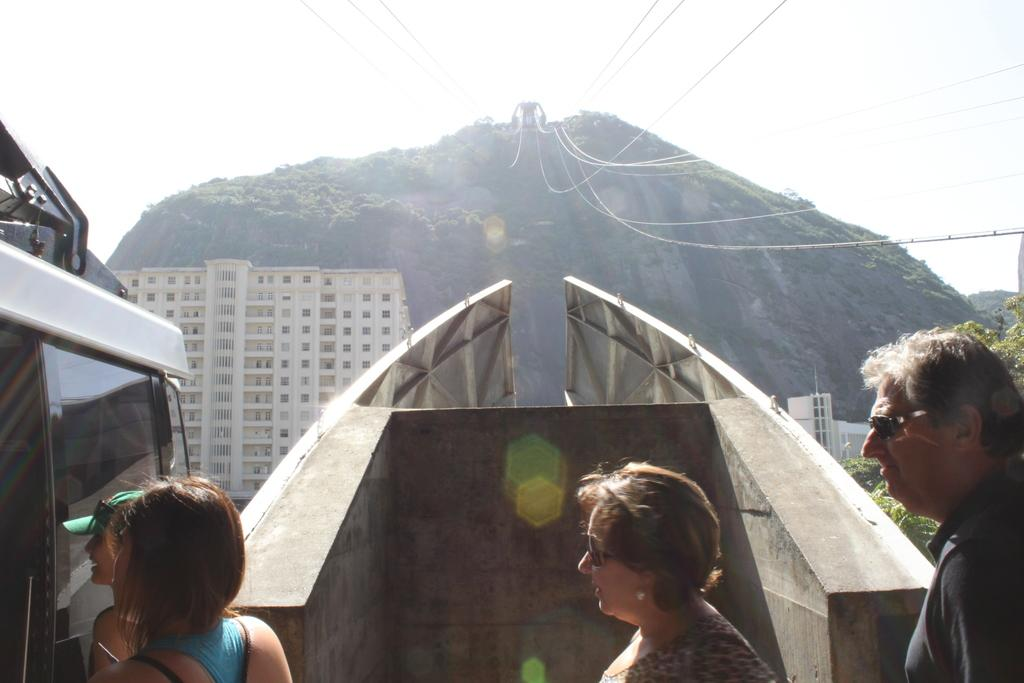What are the people standing near in the image? The people are standing near a ropeway cable car. What can be seen in the background of the image? There is a building visible in the background, and there are trees on a hill in the background. What type of songs can be heard coming from the building in the image? There is no indication in the image that any songs are being played or heard from the building. 